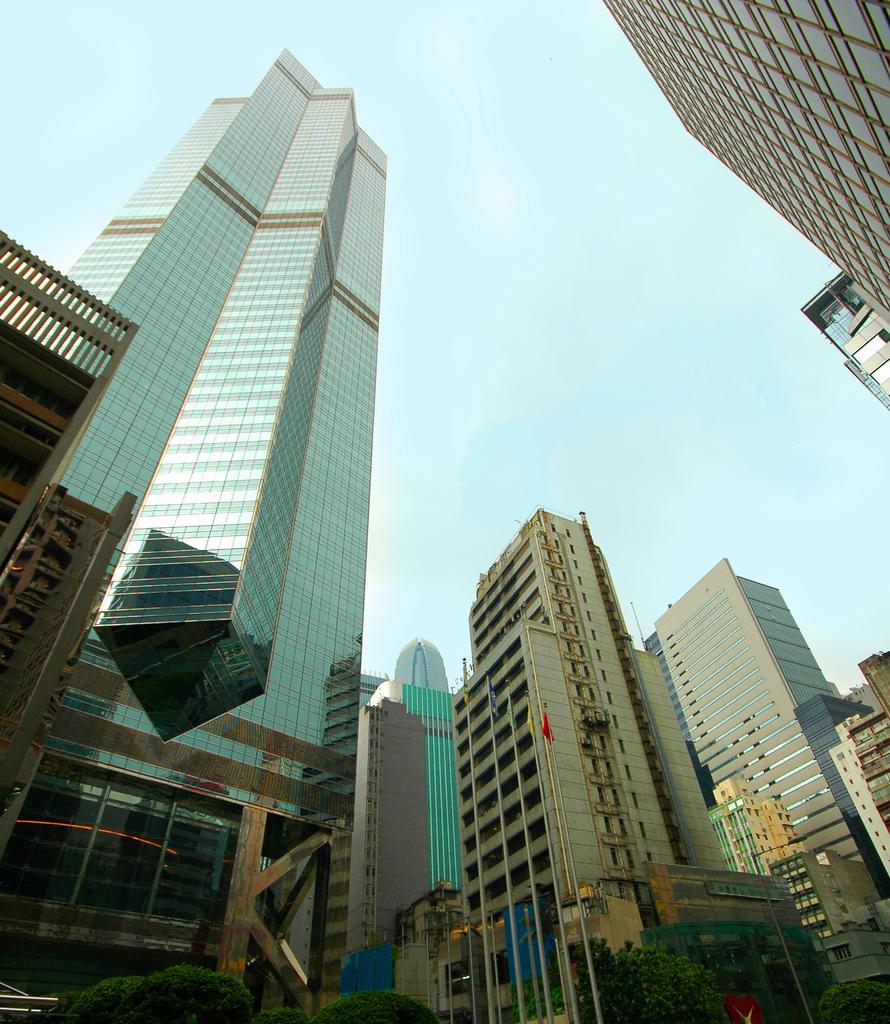Describe this image in one or two sentences. In this image we can see building, flags, poles and trees. In the background there is sky. 